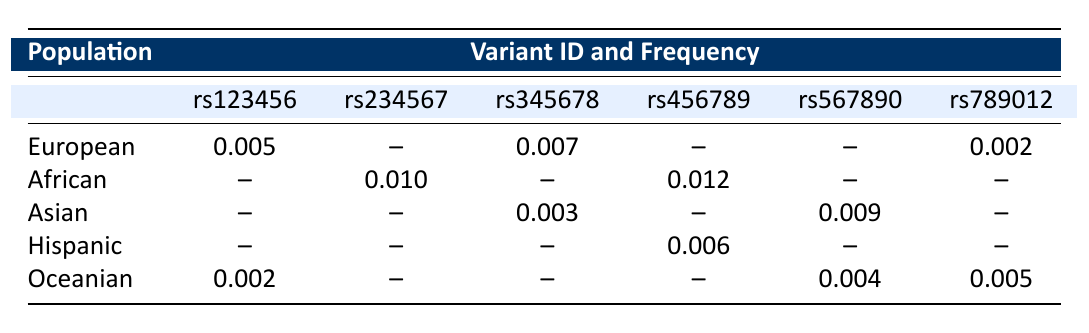What is the frequency of the variant rs123456 in the European population? The table shows that the frequency of the variant rs123456 in the European population is 0.005.
Answer: 0.005 Which population has the highest frequency for the variant rs456789? According to the table, the highest frequency of the variant rs456789 is found in the African population at 0.012.
Answer: African: 0.012 Is there any population where the variant rs901234 is recorded? The table does not show any frequency data for the variant rs901234 across any of the populations, indicating it is not recorded.
Answer: No What is the average frequency of the variant rs345678 across all populations? The frequencies for rs345678 are 0.007 (European), 0.003 (Asian), and it doesn’t appear in others. The average frequency is (0.007 + 0.003) / 2 = 0.005.
Answer: 0.005 Which population has the lowest recorded frequency value, and what is that value? Reviewing the table, the lowest frequency value is 0.001, which is reported for the Asian population for the variant rs901234.
Answer: Asian: 0.001 How many populations show a frequency for the variant rs789012, and what is the maximum observed value among them? The variant rs789012 is reported in the European (0.002), Oceanian (0.005), and there is no record in African, Asian, or Hispanic populations. The maximum value is 0.005 from Oceanian.
Answer: 2 populations, max frequency: 0.005 If we consider the frequency values for variant rs567890, how much greater is the frequency in the Asian population compared to the Oceanian population? The frequency for rs567890 in the Asian population is 0.009 and in the Oceanian population is 0.004. The difference is 0.009 - 0.004 = 0.005.
Answer: 0.005 Do any populations have a frequency greater than 0.01 for any variant? Yes, the African population has a frequency greater than 0.01 for the variant rs234567 (0.010) and rs456789 (0.012).
Answer: Yes What is the sum of the frequencies of all variants listed for the African population? The frequencies for the African population are 0.010 (rs234567) + 0.004 (rs890123) + 0.012 (rs456789), which sums to 0.010 + 0.004 + 0.012 = 0.026.
Answer: 0.026 Based on the table, which variant is the most common across all recorded populations? The variant rs456789 is recorded in both African (0.012) and Hispanic (0.006), making it the most common variant observed with the highest frequency in any single population.
Answer: rs456789 (0.012) in African 